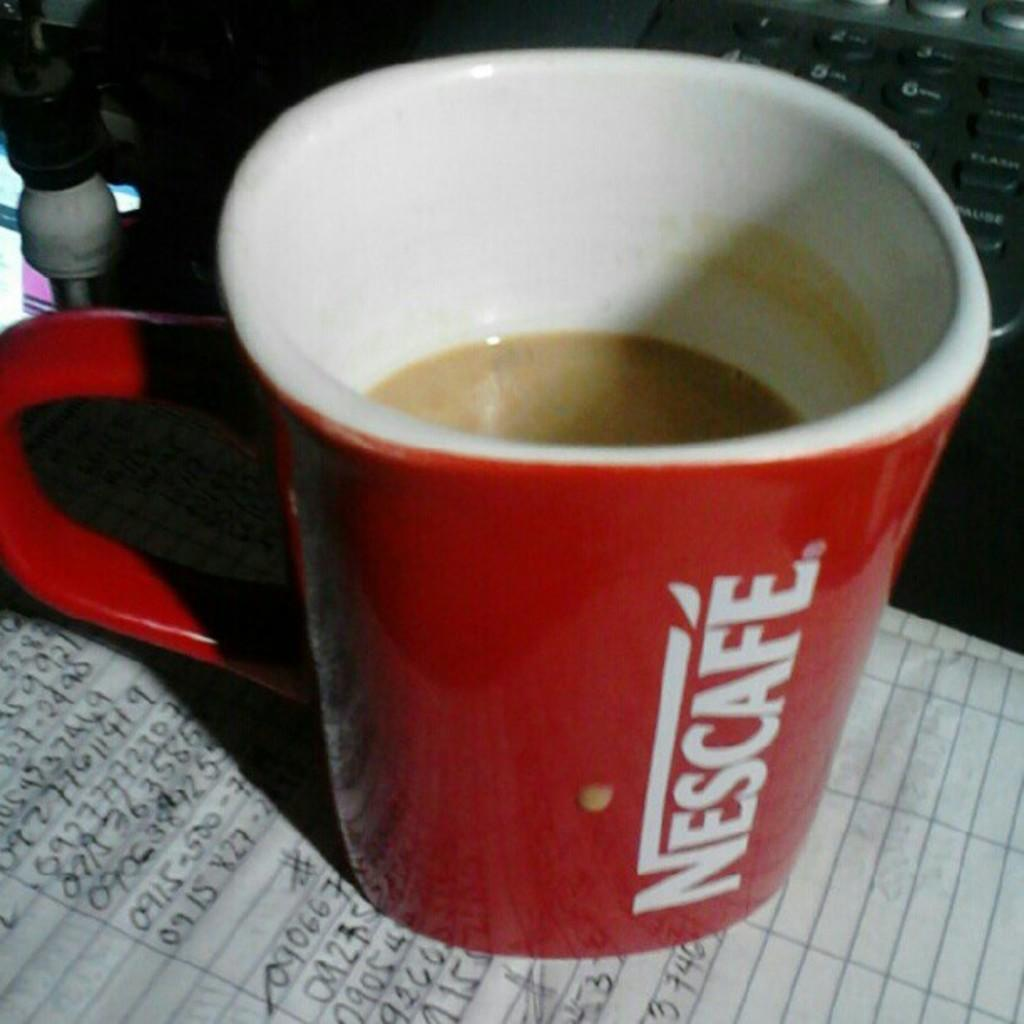Provide a one-sentence caption for the provided image. A red coffee cup with Nescafe written on the side on top of piece paper with written numbers. 